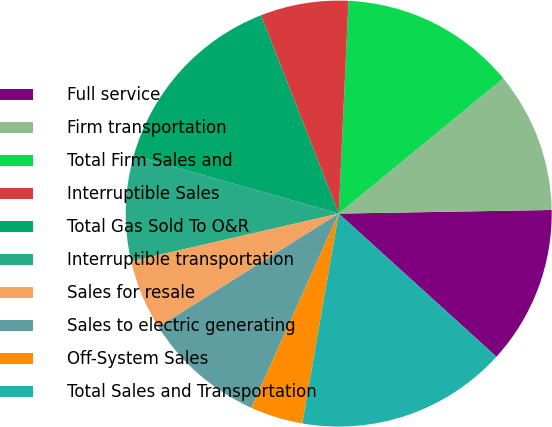Convert chart. <chart><loc_0><loc_0><loc_500><loc_500><pie_chart><fcel>Full service<fcel>Firm transportation<fcel>Total Firm Sales and<fcel>Interruptible Sales<fcel>Total Gas Sold To O&R<fcel>Interruptible transportation<fcel>Sales for resale<fcel>Sales to electric generating<fcel>Off-System Sales<fcel>Total Sales and Transportation<nl><fcel>12.0%<fcel>10.67%<fcel>13.33%<fcel>6.67%<fcel>14.66%<fcel>8.0%<fcel>5.34%<fcel>9.33%<fcel>4.0%<fcel>16.0%<nl></chart> 